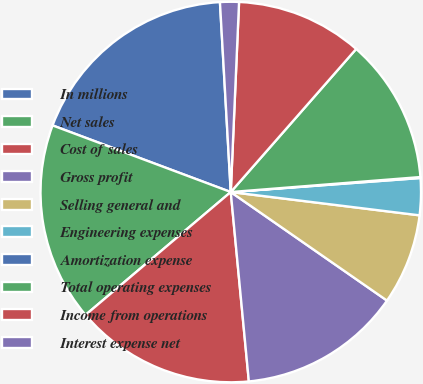Convert chart to OTSL. <chart><loc_0><loc_0><loc_500><loc_500><pie_chart><fcel>In millions<fcel>Net sales<fcel>Cost of sales<fcel>Gross profit<fcel>Selling general and<fcel>Engineering expenses<fcel>Amortization expense<fcel>Total operating expenses<fcel>Income from operations<fcel>Interest expense net<nl><fcel>18.4%<fcel>16.87%<fcel>15.34%<fcel>13.82%<fcel>7.71%<fcel>3.13%<fcel>0.08%<fcel>12.29%<fcel>10.76%<fcel>1.6%<nl></chart> 